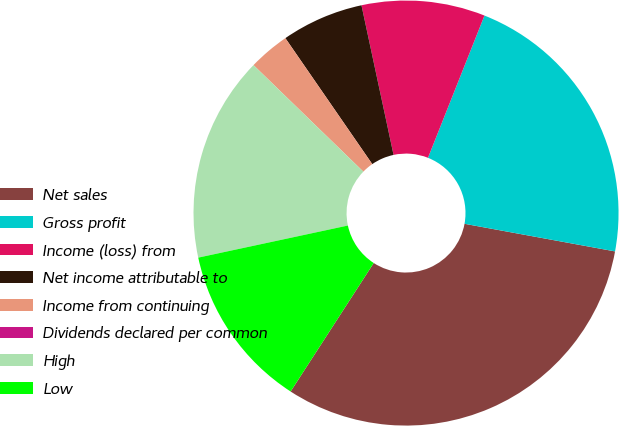<chart> <loc_0><loc_0><loc_500><loc_500><pie_chart><fcel>Net sales<fcel>Gross profit<fcel>Income (loss) from<fcel>Net income attributable to<fcel>Income from continuing<fcel>Dividends declared per common<fcel>High<fcel>Low<nl><fcel>31.25%<fcel>21.87%<fcel>9.38%<fcel>6.25%<fcel>3.13%<fcel>0.0%<fcel>15.62%<fcel>12.5%<nl></chart> 